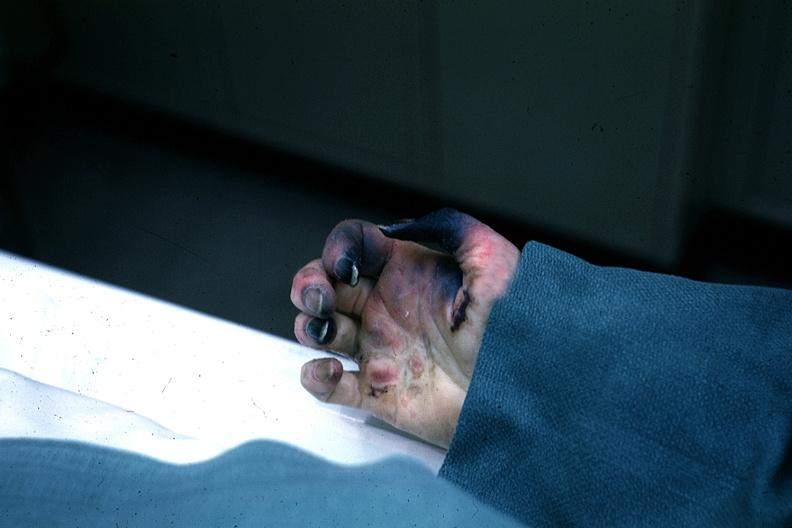re cells present?
Answer the question using a single word or phrase. No 